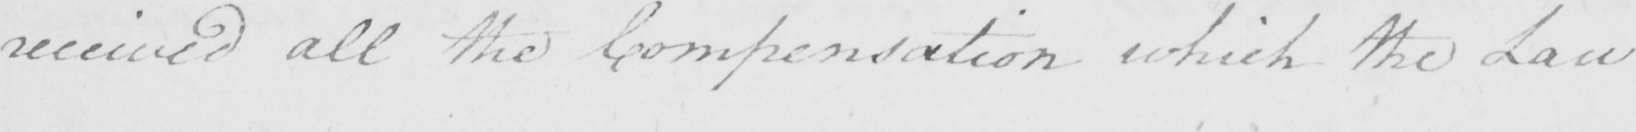Can you tell me what this handwritten text says? received all the Compensation which the Law 